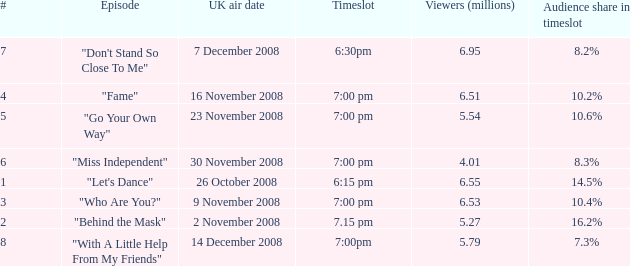Name the total number of viewers for audience share in timeslot for 10.2% 1.0. 